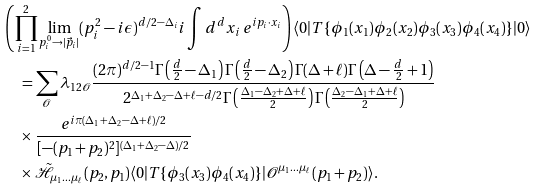<formula> <loc_0><loc_0><loc_500><loc_500>& \left ( \prod _ { i = 1 } ^ { 2 } \lim _ { p _ { i } ^ { 0 } \to | \vec { p } _ { i } | } ( p _ { i } ^ { 2 } - i \epsilon ) ^ { d / 2 - \Delta _ { i } } i \int d ^ { d } x _ { i } \, e ^ { i p _ { i } \cdot x _ { i } } \right ) \langle 0 | T \{ \phi _ { 1 } ( x _ { 1 } ) \phi _ { 2 } ( x _ { 2 } ) \phi _ { 3 } ( x _ { 3 } ) \phi _ { 4 } ( x _ { 4 } ) \} | 0 \rangle \\ & \quad = \sum _ { \mathcal { O } } \lambda _ { 1 2 \mathcal { O } } \frac { ( 2 \pi ) ^ { d / 2 - 1 } \Gamma \left ( \frac { d } { 2 } - \Delta _ { 1 } \right ) \Gamma \left ( \frac { d } { 2 } - \Delta _ { 2 } \right ) \Gamma ( \Delta + \ell ) \Gamma \left ( \Delta - \frac { d } { 2 } + 1 \right ) } { 2 ^ { \Delta _ { 1 } + \Delta _ { 2 } - \Delta + \ell - d / 2 } \Gamma \left ( \frac { \Delta _ { 1 } - \Delta _ { 2 } + \Delta + \ell } { 2 } \right ) \Gamma \left ( \frac { \Delta _ { 2 } - \Delta _ { 1 } + \Delta + \ell } { 2 } \right ) } \\ & \quad \times \frac { e ^ { i \pi ( \Delta _ { 1 } + \Delta _ { 2 } - \Delta + \ell ) / 2 } } { [ - ( p _ { 1 } + p _ { 2 } ) ^ { 2 } ] ^ { ( \Delta _ { 1 } + \Delta _ { 2 } - \Delta ) / 2 } } \\ & \quad \times \tilde { \mathcal { H } } _ { \mu _ { 1 } \dots \mu _ { \ell } } ( p _ { 2 } , p _ { 1 } ) \langle 0 | T \{ \phi _ { 3 } ( x _ { 3 } ) \phi _ { 4 } ( x _ { 4 } ) \} | \mathcal { O } ^ { \mu _ { 1 } \dots \mu _ { \ell } } ( p _ { 1 } + p _ { 2 } ) \rangle .</formula> 